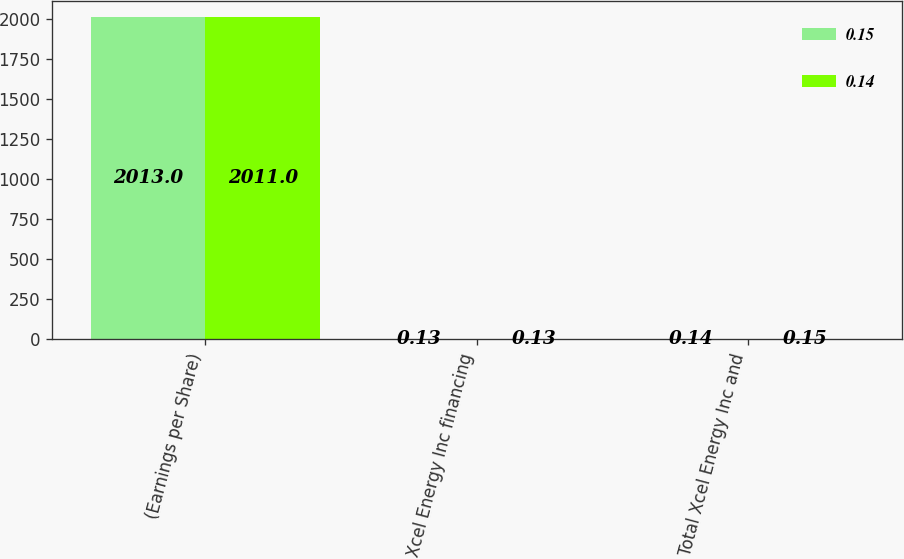Convert chart. <chart><loc_0><loc_0><loc_500><loc_500><stacked_bar_chart><ecel><fcel>(Earnings per Share)<fcel>Xcel Energy Inc financing<fcel>Total Xcel Energy Inc and<nl><fcel>0.15<fcel>2013<fcel>0.13<fcel>0.14<nl><fcel>0.14<fcel>2011<fcel>0.13<fcel>0.15<nl></chart> 